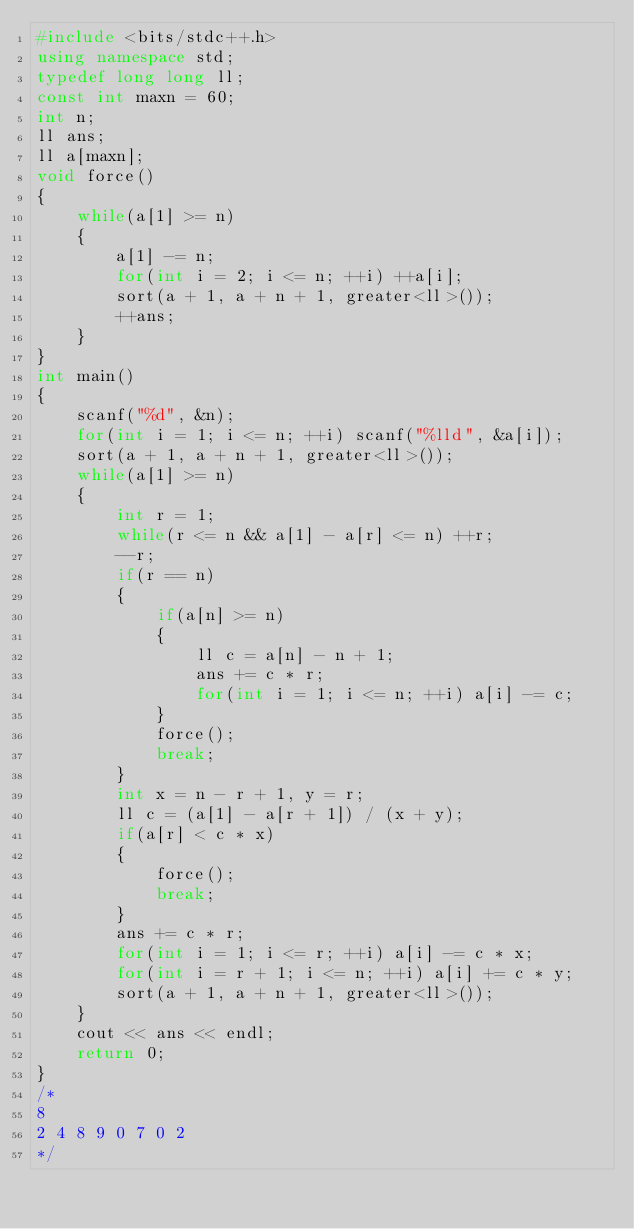Convert code to text. <code><loc_0><loc_0><loc_500><loc_500><_C++_>#include <bits/stdc++.h>
using namespace std;
typedef long long ll;
const int maxn = 60;
int n;
ll ans;
ll a[maxn];
void force()
{
	while(a[1] >= n)
	{
		a[1] -= n;
		for(int i = 2; i <= n; ++i) ++a[i];
		sort(a + 1, a + n + 1, greater<ll>());
		++ans;
	}
}
int main()
{
	scanf("%d", &n);
	for(int i = 1; i <= n; ++i) scanf("%lld", &a[i]);
	sort(a + 1, a + n + 1, greater<ll>());
	while(a[1] >= n)
	{
		int r = 1;
		while(r <= n && a[1] - a[r] <= n) ++r;
		--r;
		if(r == n)
		{
			if(a[n] >= n)
			{
				ll c = a[n] - n + 1;
				ans += c * r;
				for(int i = 1; i <= n; ++i) a[i] -= c;
			}
			force();
			break;
		}
		int x = n - r + 1, y = r;
		ll c = (a[1] - a[r + 1]) / (x + y);
		if(a[r] < c * x)
		{
			force();
			break; 
		}
		ans += c * r;
		for(int i = 1; i <= r; ++i) a[i] -= c * x;
		for(int i = r + 1; i <= n; ++i) a[i] += c * y;
		sort(a + 1, a + n + 1, greater<ll>());
	}
	cout << ans << endl;
	return 0;
}
/*
8
2 4 8 9 0 7 0 2
*/</code> 